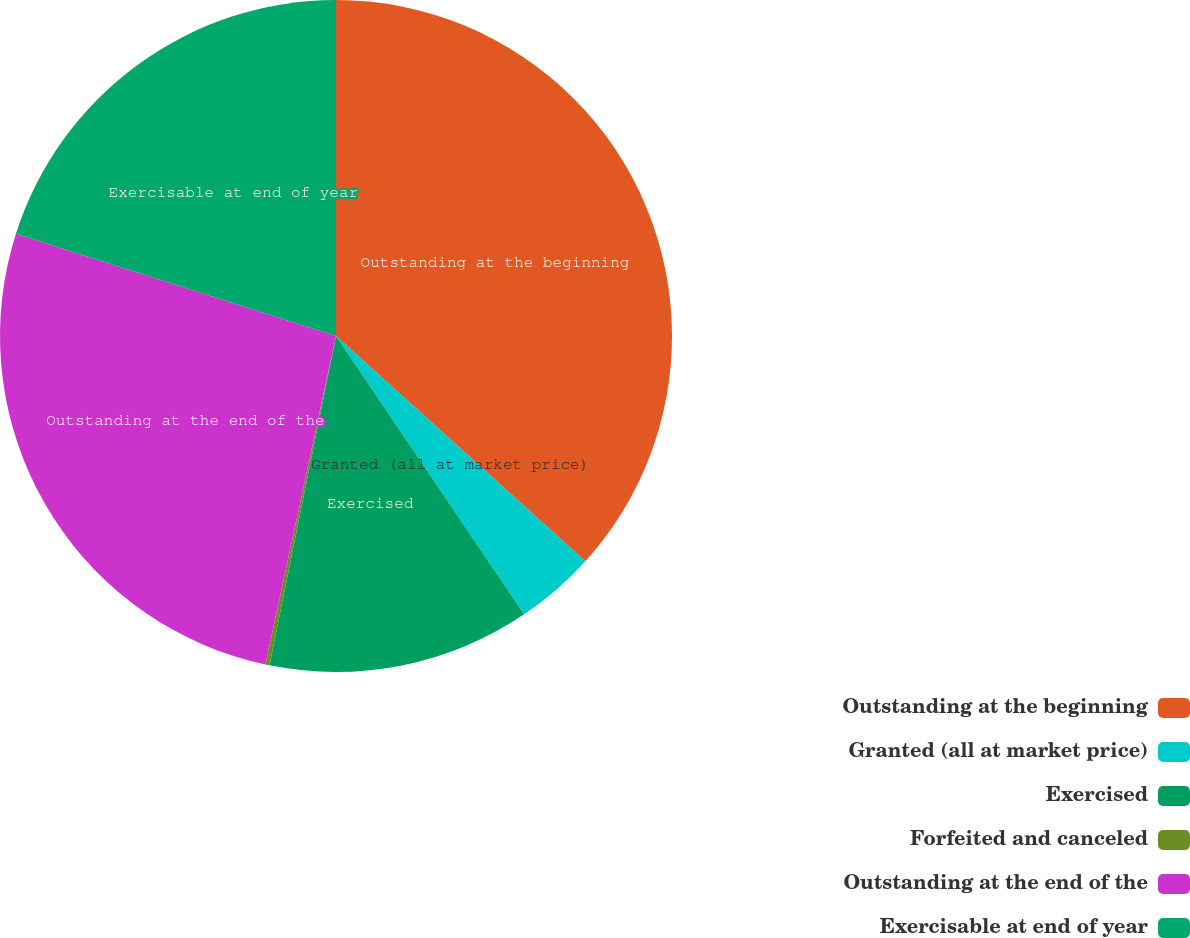Convert chart. <chart><loc_0><loc_0><loc_500><loc_500><pie_chart><fcel>Outstanding at the beginning<fcel>Granted (all at market price)<fcel>Exercised<fcel>Forfeited and canceled<fcel>Outstanding at the end of the<fcel>Exercisable at end of year<nl><fcel>36.69%<fcel>3.85%<fcel>12.63%<fcel>0.2%<fcel>26.55%<fcel>20.08%<nl></chart> 